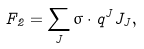Convert formula to latex. <formula><loc_0><loc_0><loc_500><loc_500>F _ { 2 } = \sum _ { J } \sigma \cdot q ^ { J } J _ { J } ,</formula> 